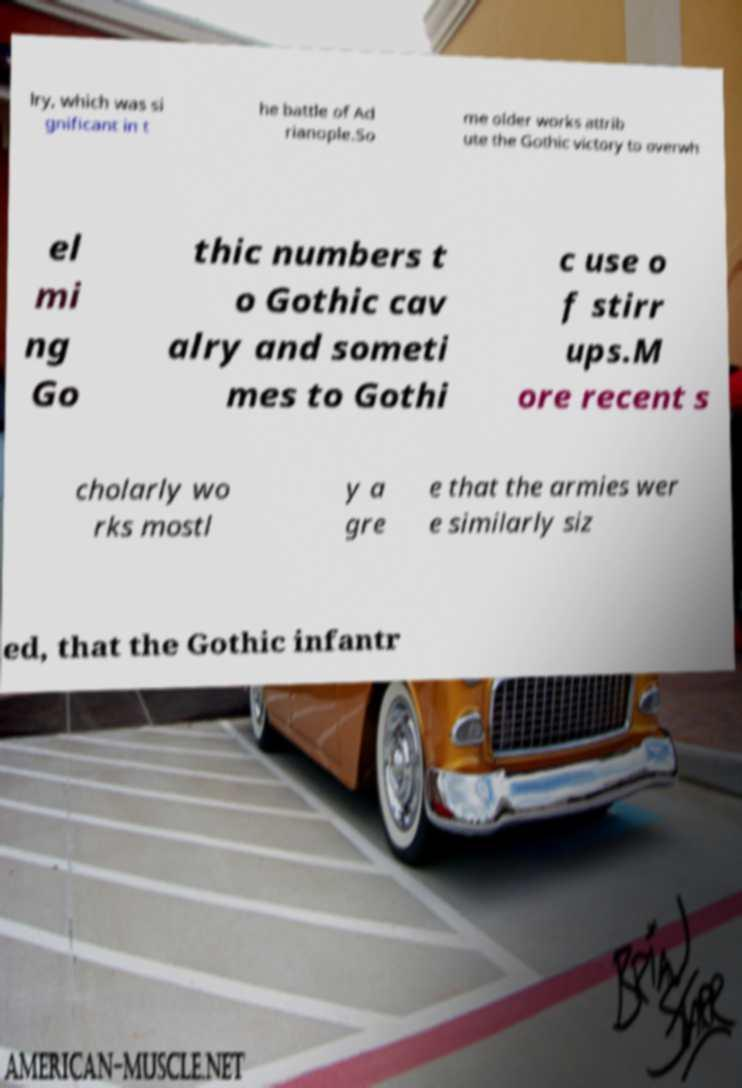Can you accurately transcribe the text from the provided image for me? lry, which was si gnificant in t he battle of Ad rianople.So me older works attrib ute the Gothic victory to overwh el mi ng Go thic numbers t o Gothic cav alry and someti mes to Gothi c use o f stirr ups.M ore recent s cholarly wo rks mostl y a gre e that the armies wer e similarly siz ed, that the Gothic infantr 